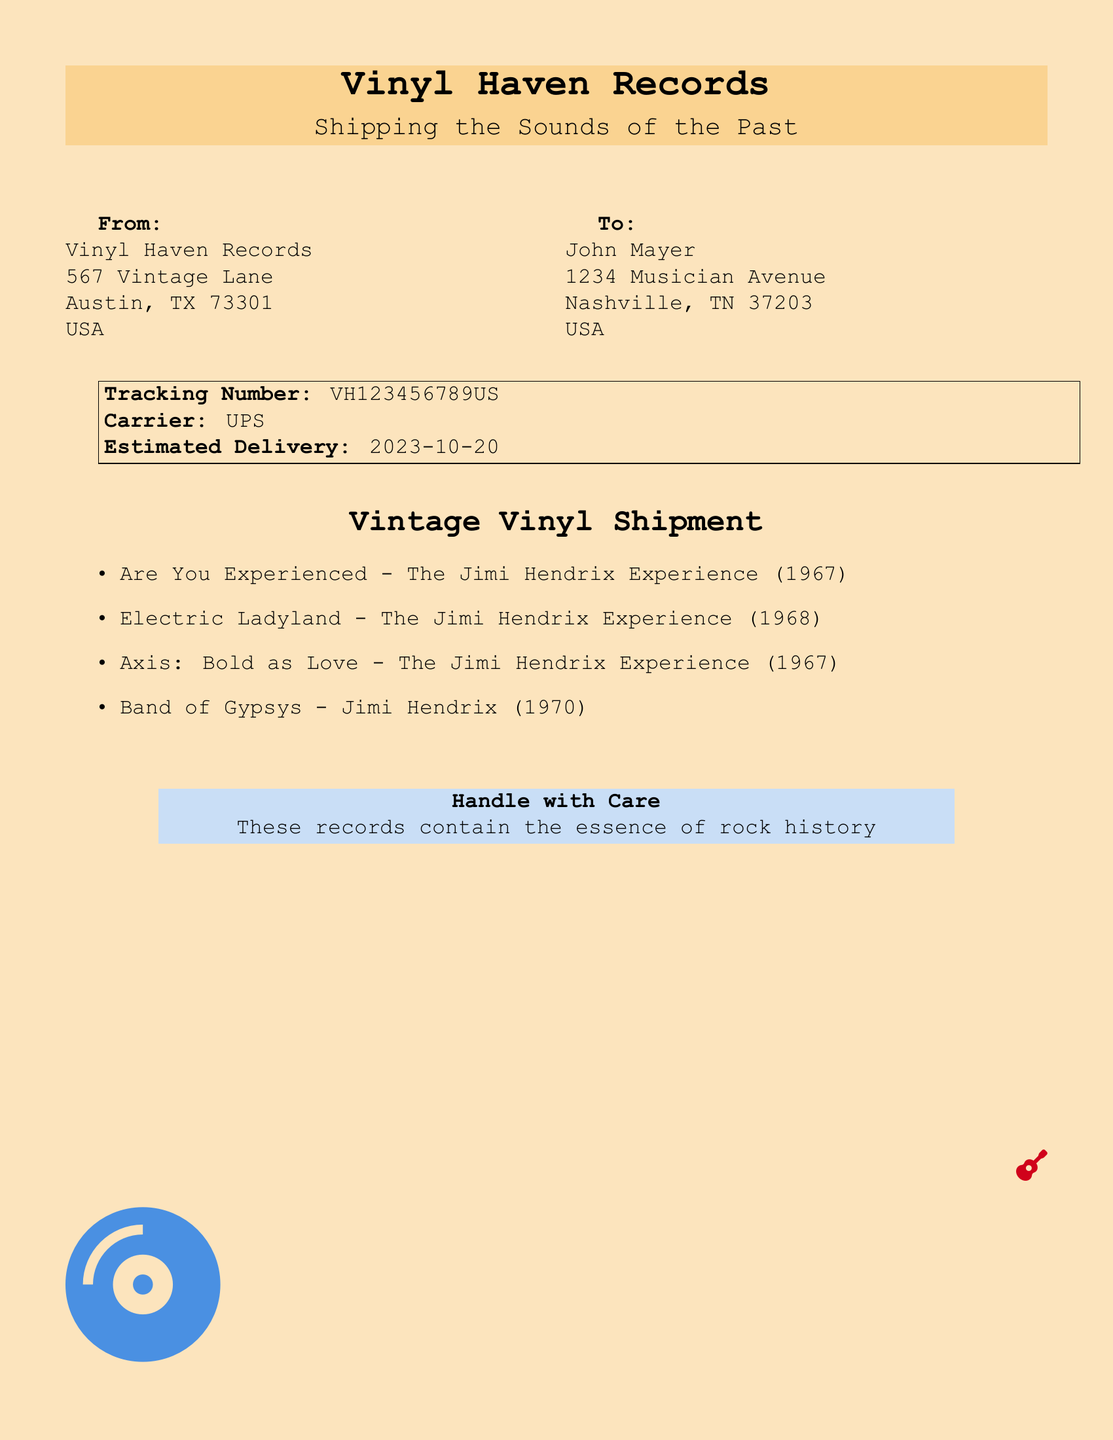What is the shipping carrier? The carrier is mentioned in the document as the service responsible for delivering the package.
Answer: UPS What is the tracking number? The tracking number is specified in the document for tracking the shipment.
Answer: VH123456789US Who is the recipient of the shipment? The document lists the name of the person receiving the records, which is necessary for delivery.
Answer: John Mayer What is the estimated delivery date? The date is provided in the document indicating when the records are expected to arrive.
Answer: 2023-10-20 How many albums are listed in the shipment? The number of albums mentioned in the itemized list within the document shows the total sent.
Answer: 4 What is the address of the sender? The sender's address is listed, critical for delivery confirmation and shipping details.
Answer: Vinyl Haven Records, 567 Vintage Lane, Austin, TX 73301, USA Which motif is used in the document design? The design aspect contributes to the visual appeal of the shipping label, requiring an understanding of its theme.
Answer: Retro What genre of music do the shipped records belong to? The mention of specific artists and albums indicates the genre represented in the shipment.
Answer: Rock Which album was released in 1967? The document contains titles along with their respective release years, allowing for identification of specific albums.
Answer: Are You Experienced What should the recipient do with the records? The document advises the recipient on how to handle the shipment, emphasizing care due to its content.
Answer: Handle with Care 